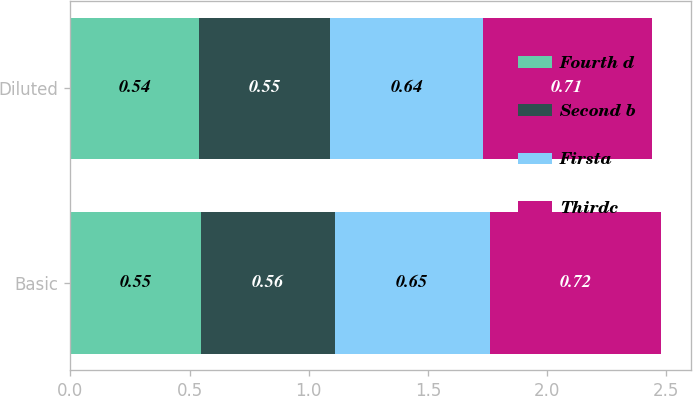Convert chart to OTSL. <chart><loc_0><loc_0><loc_500><loc_500><stacked_bar_chart><ecel><fcel>Basic<fcel>Diluted<nl><fcel>Fourth d<fcel>0.55<fcel>0.54<nl><fcel>Second b<fcel>0.56<fcel>0.55<nl><fcel>Firsta<fcel>0.65<fcel>0.64<nl><fcel>Thirdc<fcel>0.72<fcel>0.71<nl></chart> 